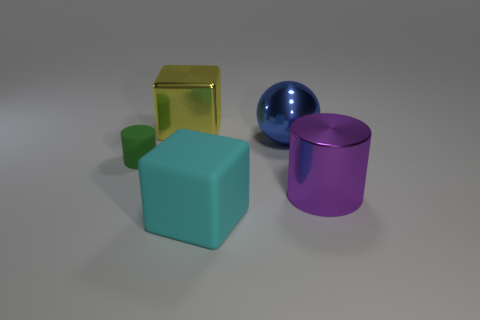Are the tiny object and the large cube that is behind the big blue thing made of the same material?
Keep it short and to the point. No. How many objects are either yellow things or big rubber balls?
Keep it short and to the point. 1. Is there a green thing that has the same shape as the big purple metallic object?
Provide a short and direct response. Yes. There is a big cylinder; what number of big blocks are behind it?
Your answer should be very brief. 1. What is the material of the cylinder on the left side of the large thing that is in front of the purple thing?
Your answer should be compact. Rubber. What is the material of the sphere that is the same size as the yellow metallic object?
Your answer should be very brief. Metal. Is there a cyan rubber thing of the same size as the yellow shiny thing?
Provide a short and direct response. Yes. What is the color of the cube behind the big metallic sphere?
Give a very brief answer. Yellow. There is a big shiny thing to the left of the sphere; is there a rubber thing that is right of it?
Keep it short and to the point. Yes. How many other things are there of the same color as the shiny ball?
Make the answer very short. 0. 